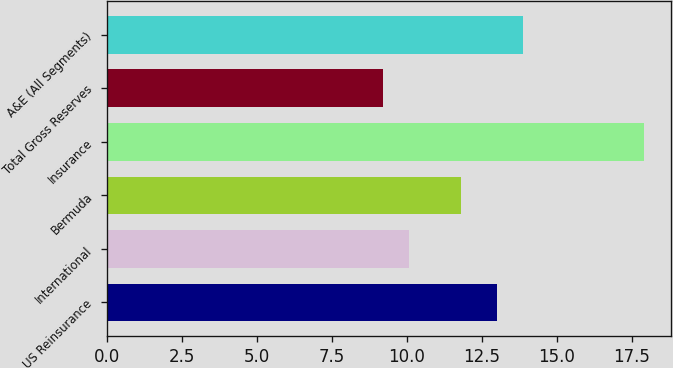<chart> <loc_0><loc_0><loc_500><loc_500><bar_chart><fcel>US Reinsurance<fcel>International<fcel>Bermuda<fcel>Insurance<fcel>Total Gross Reserves<fcel>A&E (All Segments)<nl><fcel>13<fcel>10.07<fcel>11.81<fcel>17.9<fcel>9.2<fcel>13.87<nl></chart> 